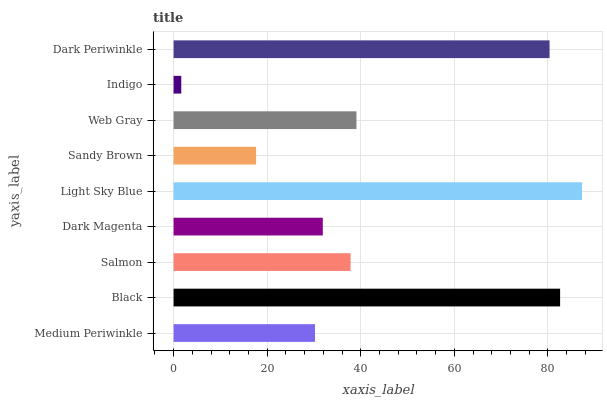Is Indigo the minimum?
Answer yes or no. Yes. Is Light Sky Blue the maximum?
Answer yes or no. Yes. Is Black the minimum?
Answer yes or no. No. Is Black the maximum?
Answer yes or no. No. Is Black greater than Medium Periwinkle?
Answer yes or no. Yes. Is Medium Periwinkle less than Black?
Answer yes or no. Yes. Is Medium Periwinkle greater than Black?
Answer yes or no. No. Is Black less than Medium Periwinkle?
Answer yes or no. No. Is Salmon the high median?
Answer yes or no. Yes. Is Salmon the low median?
Answer yes or no. Yes. Is Sandy Brown the high median?
Answer yes or no. No. Is Black the low median?
Answer yes or no. No. 